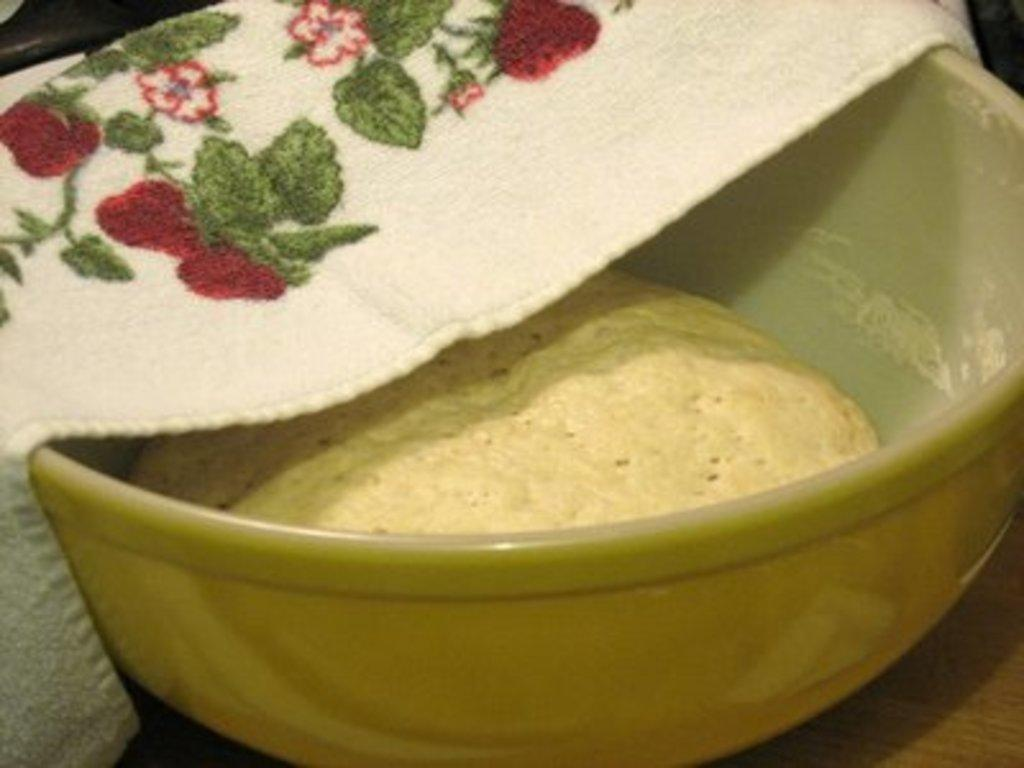What is in the bowl that is visible in the image? There is a bowl with flour in the image. Where is the bowl located in the image? The bowl is placed on a table. Is there anything covering or touching the bowl in the image? Yes, there is a napkin on the bowl. What type of stone is being used as a base for the bowl in the image? There is no stone present in the image; it features a bowl of flour with a napkin on it. 